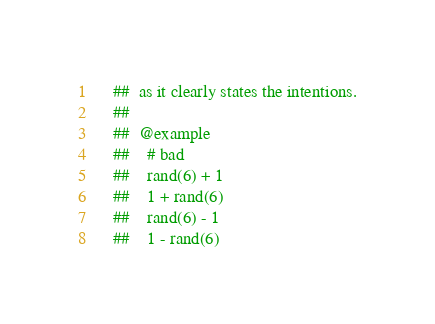<code> <loc_0><loc_0><loc_500><loc_500><_Nim_>    ##  as it clearly states the intentions.
    ## 
    ##  @example
    ##    # bad
    ##    rand(6) + 1
    ##    1 + rand(6)
    ##    rand(6) - 1
    ##    1 - rand(6)</code> 